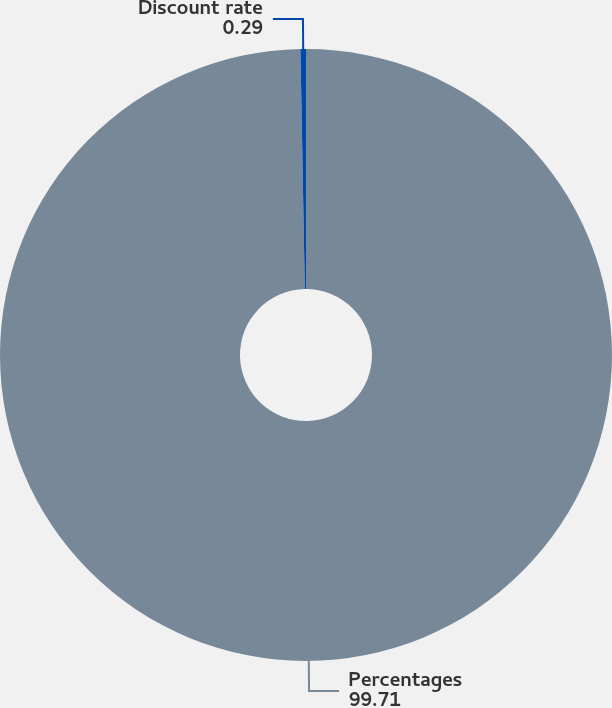Convert chart. <chart><loc_0><loc_0><loc_500><loc_500><pie_chart><fcel>Percentages<fcel>Discount rate<nl><fcel>99.71%<fcel>0.29%<nl></chart> 